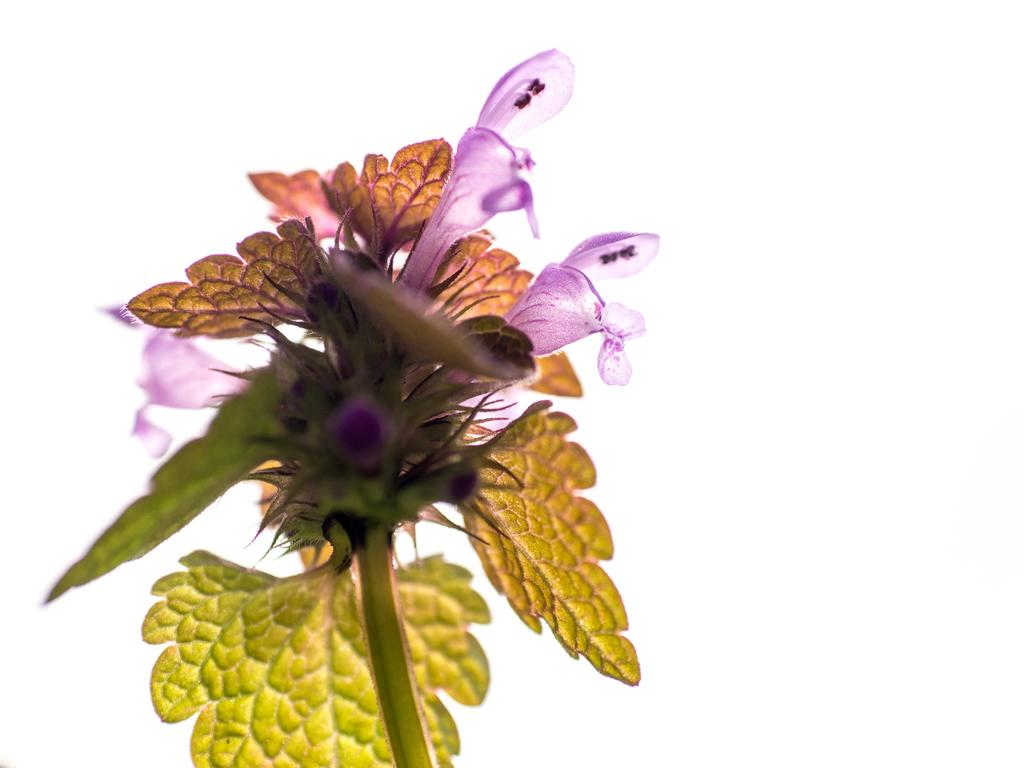What type of plant is visible in the image? There are flowers on a plant in the image. What else can be seen on the plant besides the flowers? There are leaves visible in the image. What time is displayed on the clock in the image? There is no clock present in the image; it only features a plant with flowers and leaves. 